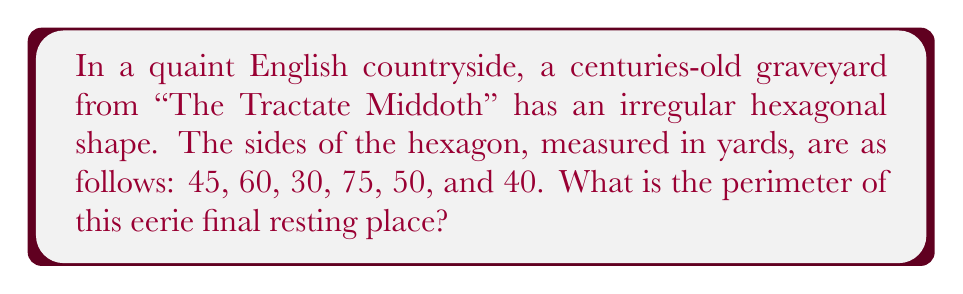Can you answer this question? To calculate the perimeter of an irregular polygon, we need to sum the lengths of all its sides. In this case, we have a hexagon with six different side lengths.

Let's add up the lengths:

$$\begin{align*}
\text{Perimeter} &= 45 + 60 + 30 + 75 + 50 + 40 \\
&= (45 + 60) + (30 + 75) + (50 + 40) \\
&= 105 + 105 + 90 \\
&= 300
\end{align*}$$

Therefore, the perimeter of the graveyard is 300 yards.

[asy]
unitsize(2mm);
pair A = (0,0);
pair B = (45,0);
pair C = (90,30);
pair D = (75,60);
pair E = (30,75);
pair F = (0,40);

draw(A--B--C--D--E--F--cycle);

label("45", (A+B)/2, S);
label("60", (B+C)/2, SE);
label("30", (C+D)/2, NE);
label("75", (D+E)/2, NW);
label("50", (E+F)/2, W);
label("40", (F+A)/2, SW);

dot(A); dot(B); dot(C); dot(D); dot(E); dot(F);
[/asy]
Answer: 300 yards 